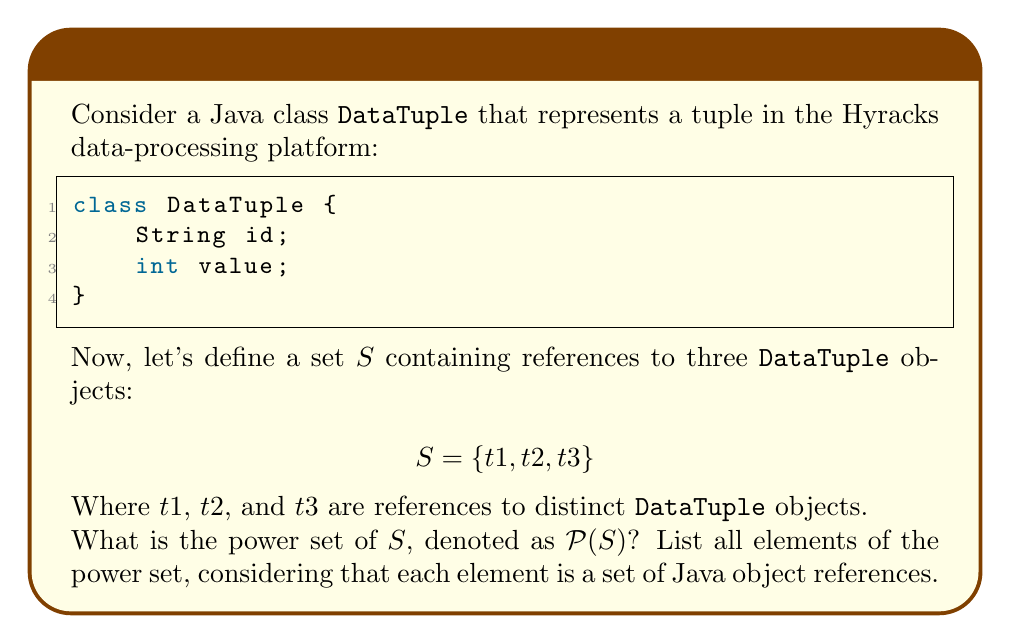Could you help me with this problem? To find the power set of $S$, we need to list all possible subsets of $S$, including the empty set and $S$ itself. Let's approach this step-by-step:

1) First, recall that for a set with $n$ elements, its power set will have $2^n$ elements. In this case, $|S| = 3$, so $|\mathcal{P}(S)| = 2^3 = 8$.

2) Now, let's list all possible subsets:

   a) The empty set: $\{\}$
   b) Sets with one element: $\{t1\}$, $\{t2\}$, $\{t3\}$
   c) Sets with two elements: $\{t1, t2\}$, $\{t1, t3\}$, $\{t2, t3\}$
   d) The set $S$ itself: $\{t1, t2, t3\}$

3) In the context of Java object references, it's important to note that these sets contain references to `DataTuple` objects, not the objects themselves. This distinction is crucial in Java, as it affects how these sets would be handled in memory and during comparisons.

4) In a Hyracks context, these object references could represent tuples in a distributed data processing pipeline. The power set could be useful in scenarios where you need to consider all possible combinations of these tuples, such as in join operations or when generating subsets of data for parallel processing.

5) The final power set $\mathcal{P}(S)$ is the set of all these subsets.
Answer: $$\mathcal{P}(S) = \{\{\}, \{t1\}, \{t2\}, \{t3\}, \{t1, t2\}, \{t1, t3\}, \{t2, t3\}, \{t1, t2, t3\}\}$$ 